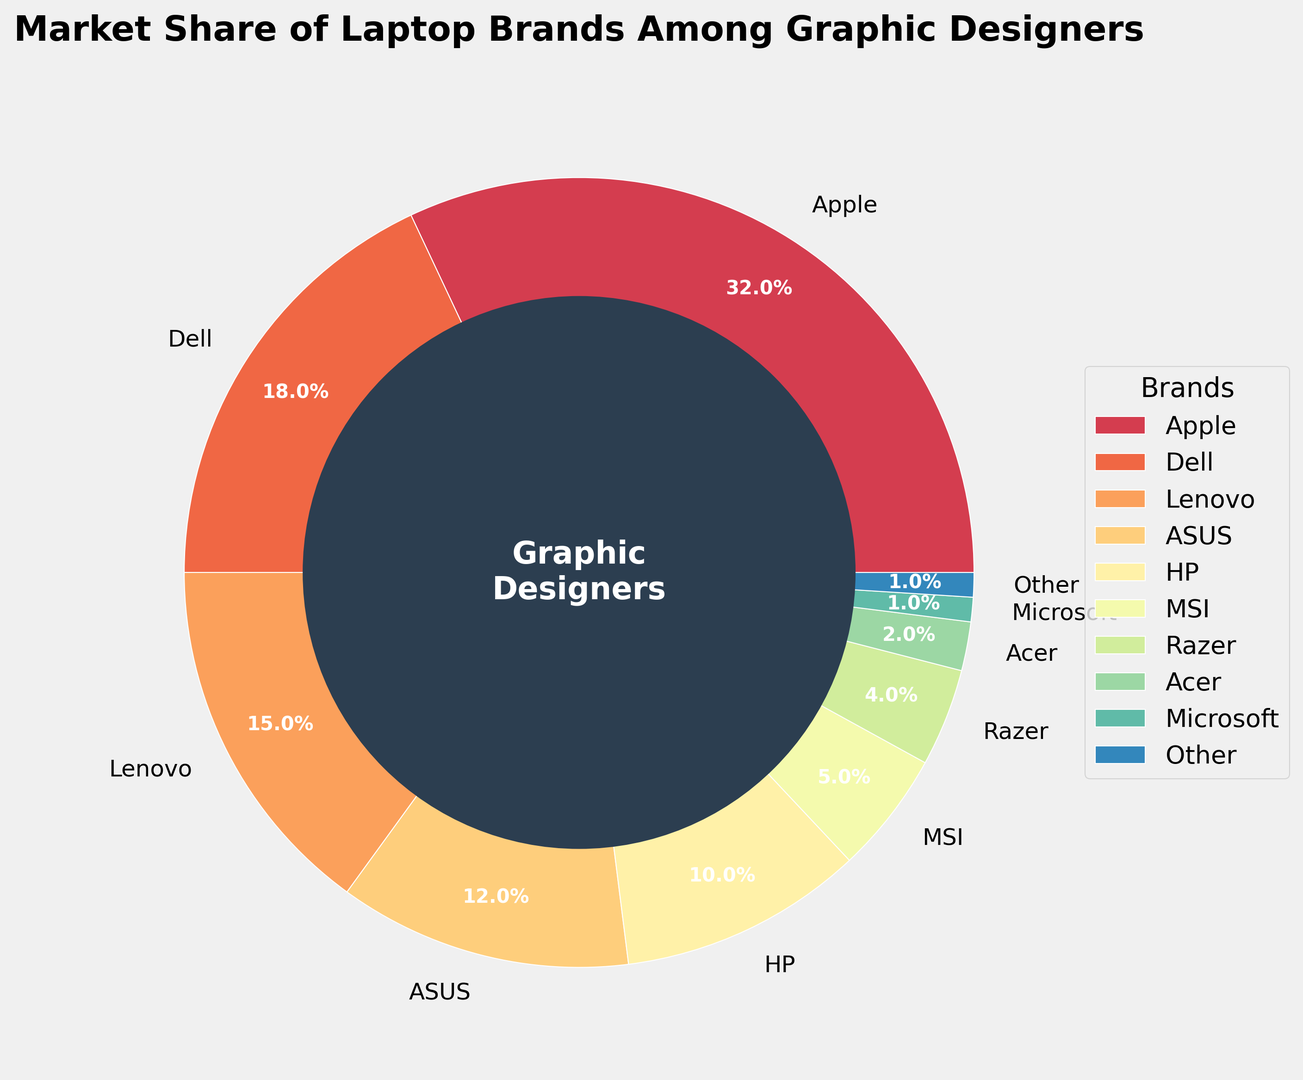What's the most popular laptop brand among graphic designers? The pie chart shows that Apple has the largest slice with 32% market share.
Answer: Apple Which brand has the smallest market share, and what percentage is it? The smallest slice is labeled "Other" with a 1% market share.
Answer: Other, 1% What is the combined market share of Dell and Lenovo? Dell's market share is 18%, and Lenovo's is 15%. The combined market share is 18% + 15% = 33%.
Answer: 33% Which brands have a market share greater than 10%? The pie chart shows that Apple (32%), Dell (18%), Lenovo (15%), and ASUS (12%) have market shares greater than 10%.
Answer: Apple, Dell, Lenovo, ASUS How much larger is Apple's market share compared to HP's? Apple's market share is 32%, and HP's is 10%. The difference is 32% - 10% = 22%.
Answer: 22% What is the total market share of the brands with less than 5% each? MSI has 5%, Razer has 4%, Acer has 2%, and Microsoft has 1%, totaling 5% + 4% + 2% + 1% = 12%.
Answer: 12% Which segment of the pie chart is colored dark green? Since the colors are assigned in a gradient and without the actual chart, it is not possible to accurately determine which brand is represented by dark green.
Answer: Not determinable from the data provided What percentage of the market is held by brands other than Apple, Dell, and Lenovo? The combined market share for Apple (32%), Dell (18%), and Lenovo (15%) is 32% + 18% + 15% = 65%. The remaining market share is 100% - 65% = 35%.
Answer: 35% Which brand has a market share closest to that of ASUS? The pie chart indicates that HP has a market share of 10%, which is closest to ASUS's 12%.
Answer: HP What's the ratio of Razer's market share to Microsoft's? Razer's market share is 4%, and Microsoft's is 1%. The ratio is 4% / 1% = 4.
Answer: 4:1 